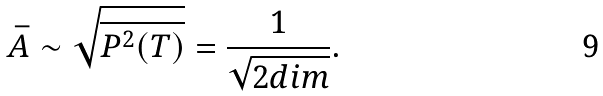<formula> <loc_0><loc_0><loc_500><loc_500>\bar { A } \sim \sqrt { \overline { P ^ { 2 } ( T ) } } = \frac { 1 } { \sqrt { 2 d i m } } .</formula> 